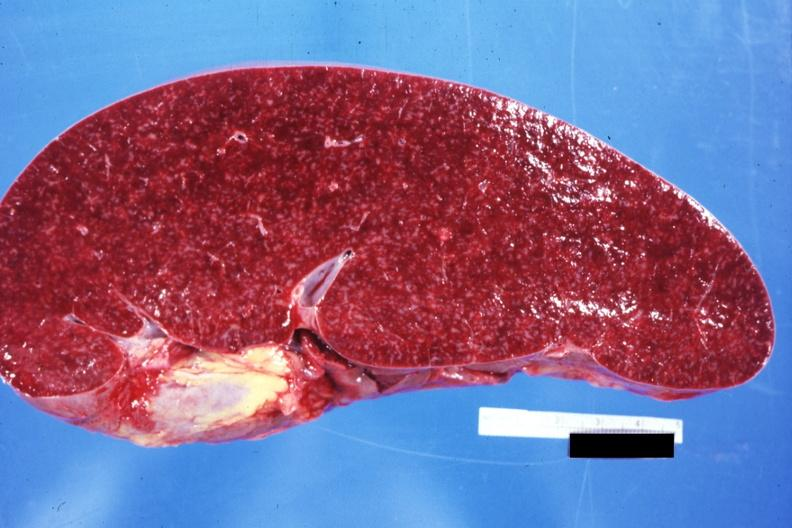what does cut surface prominent lymph follicles size appear?
Answer the question using a single word or phrase. Normal see other sides this case 